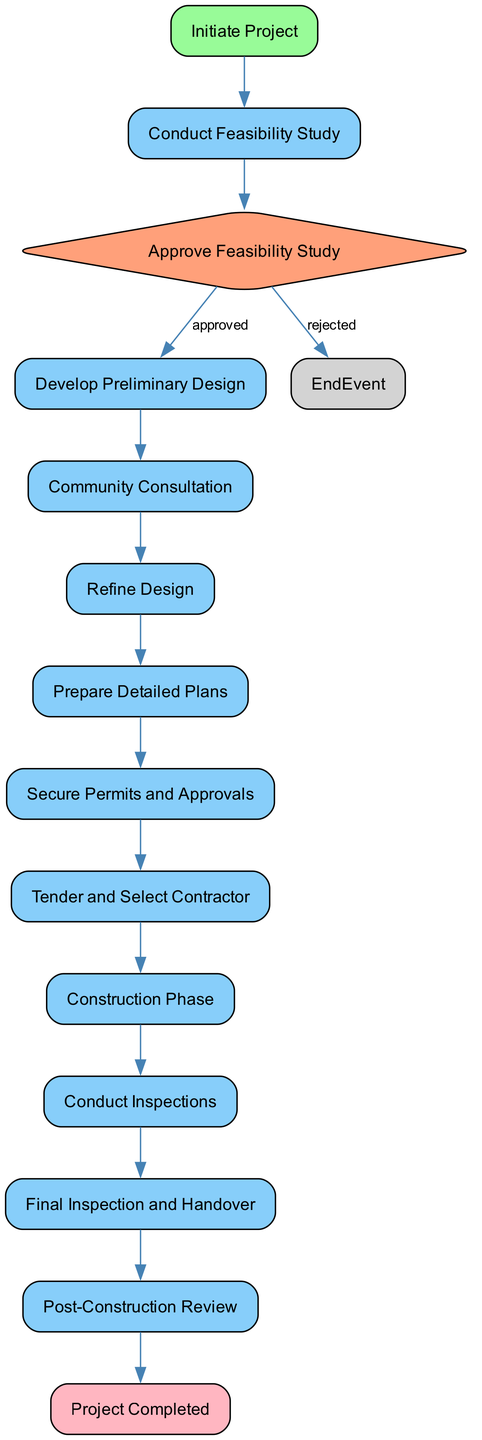What is the first step in the project? The first step identified in the diagram is "Initiate Project," which is represented as the starting event.
Answer: Initiate Project How many activities are there in total? Counting the nodes of type "Activity," there are a total of eight activities in the diagram.
Answer: 8 What happens after the "Approve Feasibility Study"? Following the "Approve Feasibility Study" decision node, the flow proceeds to "Develop Preliminary Design" if the project is approved.
Answer: Develop Preliminary Design Which node represents the final step of the project? The final step in the project, indicated by an end event, is "Project Completed." This is the terminal state of the process as per the diagram.
Answer: Project Completed What is the purpose of the "Conduct Inspections" activity? The purpose of the "Conduct Inspections" activity is to regularly inspect construction progress and quality during the construction phase.
Answer: Regularly inspect construction progress and quality What do the different colors in the diagram signify? The colors in the diagram indicate the type of nodes: green for start events, light blue for activities, light salmon for decisions, and light pink for end events.
Answer: Type of nodes color coding How many decision nodes are present in the diagram? There is a total of one decision node, "Approve Feasibility Study," which dictates whether the project proceeds or not based on feasibility results.
Answer: 1 What is the link between "Community Consultation" and "Refine Design"? The "Community Consultation" leads to the "Refine Design" activity, where feedback from the community is incorporated to finalize the design.
Answer: Feedback incorporation to finalize design What is required before the "Construction Phase" can begin? Before "Construction Phase" can start, it is necessary to "Secure Permits and Approvals" from local authorities as indicated in the diagram.
Answer: Secure Permits and Approvals 